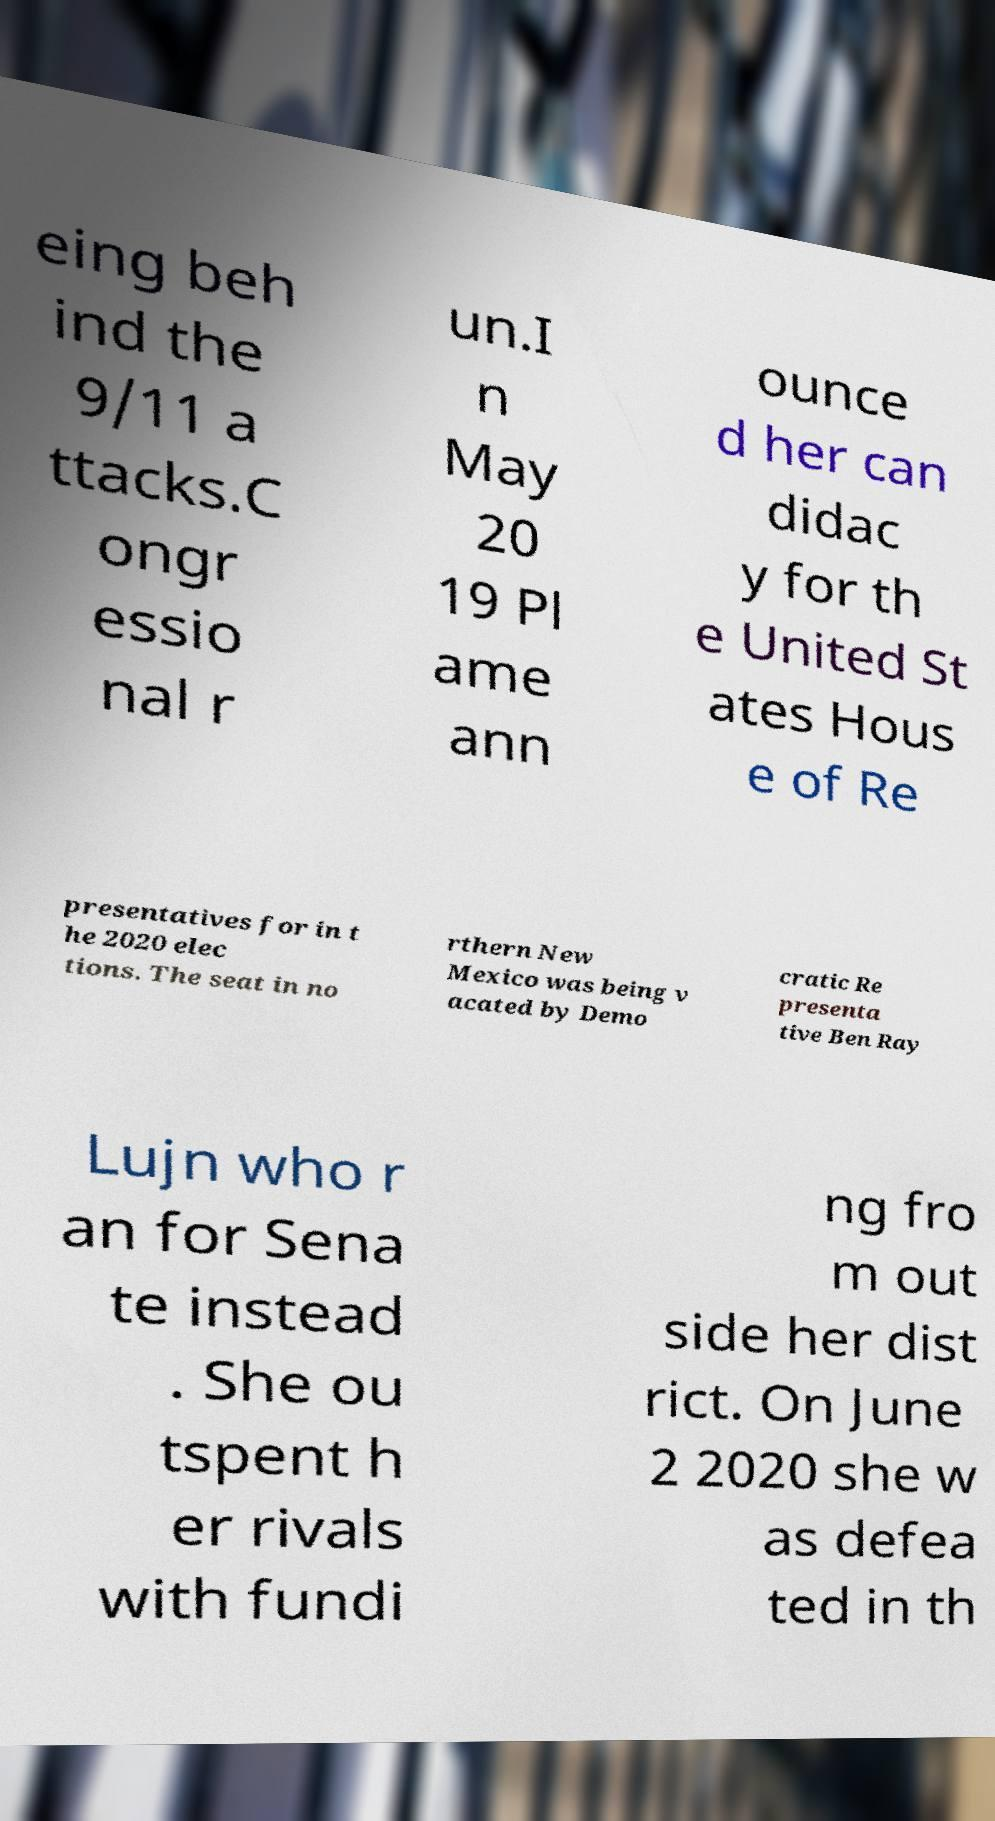Please identify and transcribe the text found in this image. eing beh ind the 9/11 a ttacks.C ongr essio nal r un.I n May 20 19 Pl ame ann ounce d her can didac y for th e United St ates Hous e of Re presentatives for in t he 2020 elec tions. The seat in no rthern New Mexico was being v acated by Demo cratic Re presenta tive Ben Ray Lujn who r an for Sena te instead . She ou tspent h er rivals with fundi ng fro m out side her dist rict. On June 2 2020 she w as defea ted in th 